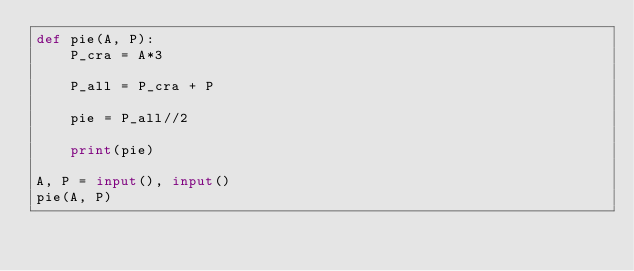Convert code to text. <code><loc_0><loc_0><loc_500><loc_500><_Python_>def pie(A, P):
    P_cra = A*3

    P_all = P_cra + P

    pie = P_all//2

    print(pie)

A, P = input(), input()
pie(A, P)
    </code> 